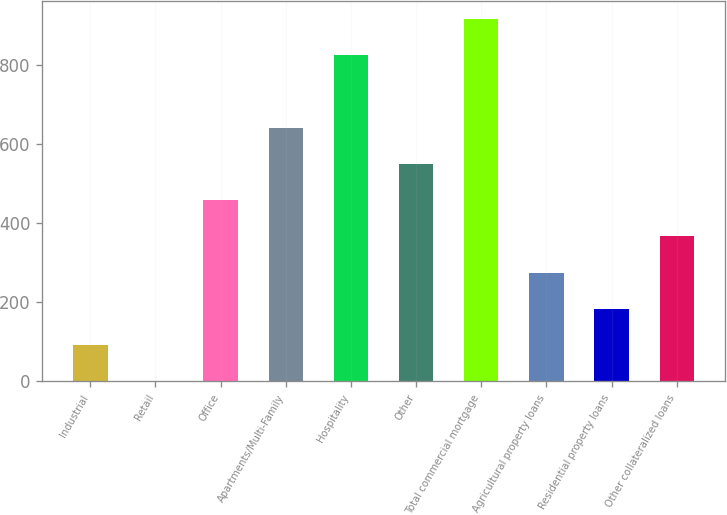Convert chart. <chart><loc_0><loc_0><loc_500><loc_500><bar_chart><fcel>Industrial<fcel>Retail<fcel>Office<fcel>Apartments/Multi-Family<fcel>Hospitality<fcel>Other<fcel>Total commercial mortgage<fcel>Agricultural property loans<fcel>Residential property loans<fcel>Other collateralized loans<nl><fcel>91.84<fcel>0.15<fcel>458.6<fcel>641.97<fcel>825.34<fcel>550.29<fcel>917.03<fcel>275.22<fcel>183.53<fcel>366.91<nl></chart> 